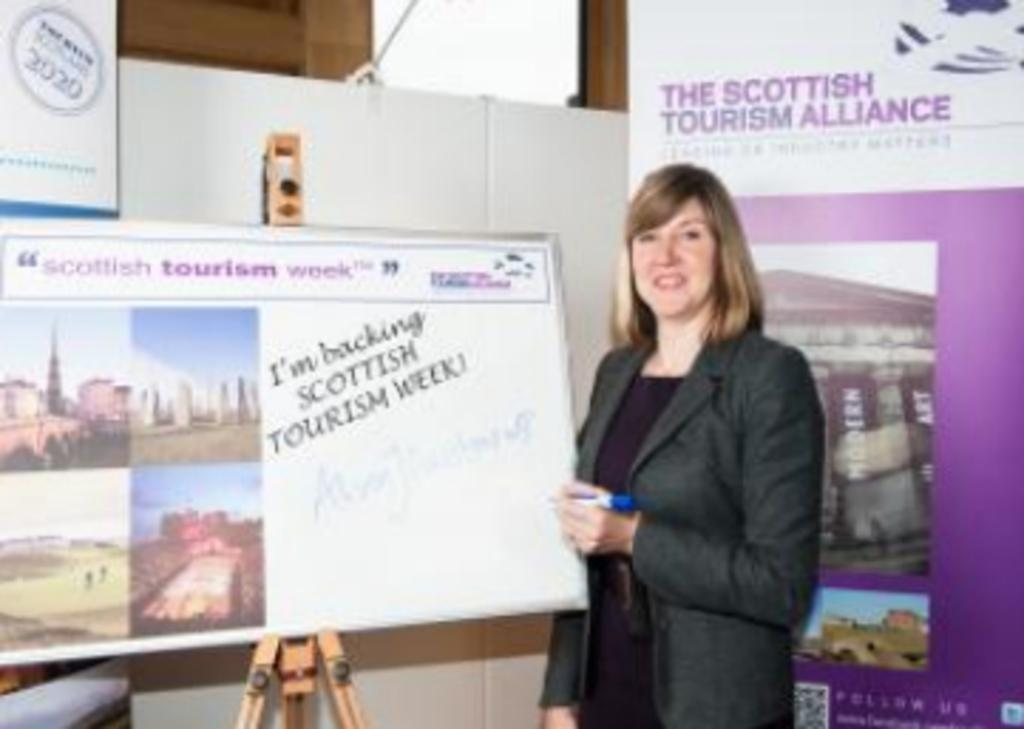What is the woman in the image holding? The woman is holding a sketch. What can be seen beside the woman in the image? There is a board with a stand beside the woman. What is visible in the background of the image? There is a banner, a board, and a wall in the background of the image. What type of chain is hanging from the shelf in the image? There is no shelf or chain present in the image. What border is visible around the board in the background of the image? There is no border visible around the board in the background of the image. 